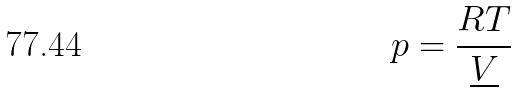Convert formula to latex. <formula><loc_0><loc_0><loc_500><loc_500>p = \frac { R T } { \underline { V } }</formula> 